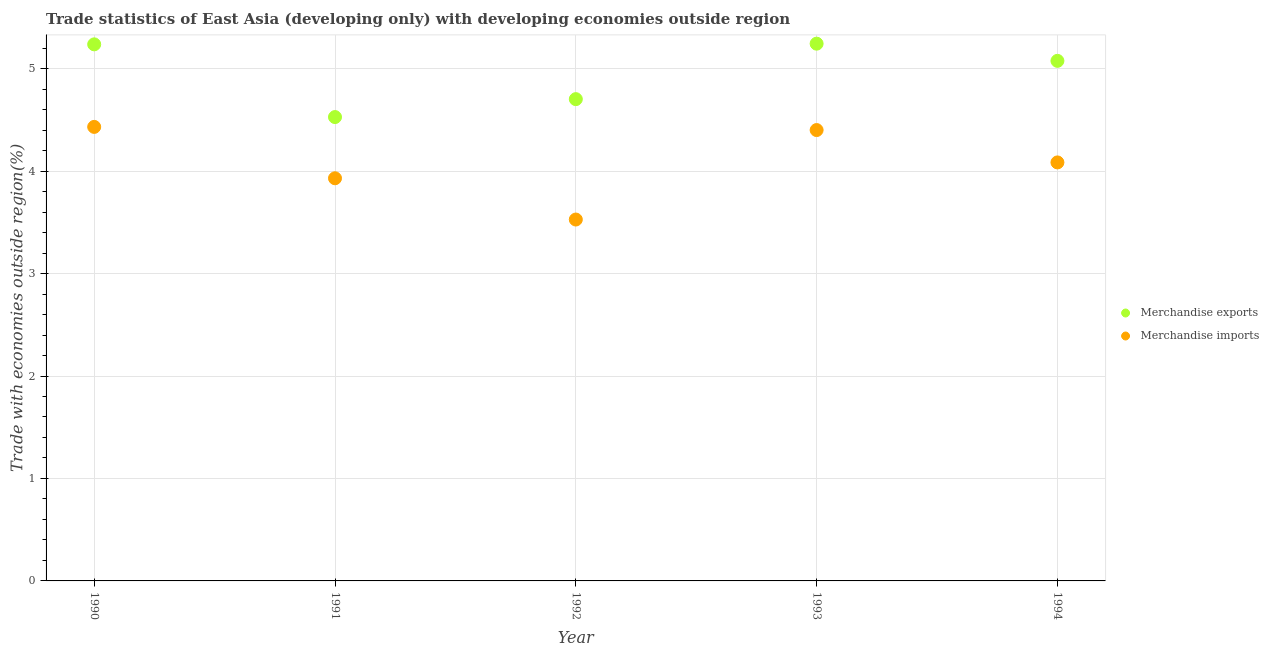What is the merchandise imports in 1993?
Your response must be concise. 4.4. Across all years, what is the maximum merchandise exports?
Give a very brief answer. 5.24. Across all years, what is the minimum merchandise exports?
Keep it short and to the point. 4.53. What is the total merchandise exports in the graph?
Keep it short and to the point. 24.79. What is the difference between the merchandise imports in 1990 and that in 1993?
Provide a succinct answer. 0.03. What is the difference between the merchandise imports in 1994 and the merchandise exports in 1992?
Offer a very short reply. -0.62. What is the average merchandise imports per year?
Your answer should be compact. 4.07. In the year 1990, what is the difference between the merchandise imports and merchandise exports?
Provide a short and direct response. -0.81. What is the ratio of the merchandise imports in 1990 to that in 1994?
Your answer should be compact. 1.08. Is the merchandise exports in 1990 less than that in 1993?
Your answer should be compact. Yes. What is the difference between the highest and the second highest merchandise imports?
Your answer should be compact. 0.03. What is the difference between the highest and the lowest merchandise imports?
Provide a short and direct response. 0.9. Is the merchandise imports strictly less than the merchandise exports over the years?
Provide a short and direct response. Yes. How many dotlines are there?
Offer a terse response. 2. How many years are there in the graph?
Provide a succinct answer. 5. Where does the legend appear in the graph?
Offer a terse response. Center right. What is the title of the graph?
Keep it short and to the point. Trade statistics of East Asia (developing only) with developing economies outside region. Does "Techinal cooperation" appear as one of the legend labels in the graph?
Your answer should be very brief. No. What is the label or title of the X-axis?
Your answer should be very brief. Year. What is the label or title of the Y-axis?
Your response must be concise. Trade with economies outside region(%). What is the Trade with economies outside region(%) in Merchandise exports in 1990?
Make the answer very short. 5.24. What is the Trade with economies outside region(%) in Merchandise imports in 1990?
Provide a succinct answer. 4.43. What is the Trade with economies outside region(%) in Merchandise exports in 1991?
Your answer should be very brief. 4.53. What is the Trade with economies outside region(%) of Merchandise imports in 1991?
Give a very brief answer. 3.93. What is the Trade with economies outside region(%) in Merchandise exports in 1992?
Provide a short and direct response. 4.7. What is the Trade with economies outside region(%) in Merchandise imports in 1992?
Make the answer very short. 3.53. What is the Trade with economies outside region(%) of Merchandise exports in 1993?
Ensure brevity in your answer.  5.24. What is the Trade with economies outside region(%) of Merchandise imports in 1993?
Make the answer very short. 4.4. What is the Trade with economies outside region(%) in Merchandise exports in 1994?
Ensure brevity in your answer.  5.08. What is the Trade with economies outside region(%) in Merchandise imports in 1994?
Provide a short and direct response. 4.08. Across all years, what is the maximum Trade with economies outside region(%) of Merchandise exports?
Provide a succinct answer. 5.24. Across all years, what is the maximum Trade with economies outside region(%) in Merchandise imports?
Offer a terse response. 4.43. Across all years, what is the minimum Trade with economies outside region(%) of Merchandise exports?
Your response must be concise. 4.53. Across all years, what is the minimum Trade with economies outside region(%) of Merchandise imports?
Keep it short and to the point. 3.53. What is the total Trade with economies outside region(%) of Merchandise exports in the graph?
Keep it short and to the point. 24.79. What is the total Trade with economies outside region(%) of Merchandise imports in the graph?
Give a very brief answer. 20.37. What is the difference between the Trade with economies outside region(%) of Merchandise exports in 1990 and that in 1991?
Your answer should be very brief. 0.71. What is the difference between the Trade with economies outside region(%) in Merchandise imports in 1990 and that in 1991?
Offer a terse response. 0.5. What is the difference between the Trade with economies outside region(%) in Merchandise exports in 1990 and that in 1992?
Your answer should be compact. 0.53. What is the difference between the Trade with economies outside region(%) of Merchandise imports in 1990 and that in 1992?
Keep it short and to the point. 0.9. What is the difference between the Trade with economies outside region(%) of Merchandise exports in 1990 and that in 1993?
Offer a terse response. -0.01. What is the difference between the Trade with economies outside region(%) in Merchandise imports in 1990 and that in 1993?
Give a very brief answer. 0.03. What is the difference between the Trade with economies outside region(%) in Merchandise exports in 1990 and that in 1994?
Make the answer very short. 0.16. What is the difference between the Trade with economies outside region(%) of Merchandise imports in 1990 and that in 1994?
Give a very brief answer. 0.35. What is the difference between the Trade with economies outside region(%) of Merchandise exports in 1991 and that in 1992?
Offer a very short reply. -0.17. What is the difference between the Trade with economies outside region(%) in Merchandise imports in 1991 and that in 1992?
Your answer should be very brief. 0.4. What is the difference between the Trade with economies outside region(%) in Merchandise exports in 1991 and that in 1993?
Offer a very short reply. -0.72. What is the difference between the Trade with economies outside region(%) of Merchandise imports in 1991 and that in 1993?
Your answer should be very brief. -0.47. What is the difference between the Trade with economies outside region(%) in Merchandise exports in 1991 and that in 1994?
Provide a short and direct response. -0.55. What is the difference between the Trade with economies outside region(%) of Merchandise imports in 1991 and that in 1994?
Your response must be concise. -0.15. What is the difference between the Trade with economies outside region(%) of Merchandise exports in 1992 and that in 1993?
Offer a very short reply. -0.54. What is the difference between the Trade with economies outside region(%) in Merchandise imports in 1992 and that in 1993?
Offer a terse response. -0.87. What is the difference between the Trade with economies outside region(%) of Merchandise exports in 1992 and that in 1994?
Make the answer very short. -0.37. What is the difference between the Trade with economies outside region(%) in Merchandise imports in 1992 and that in 1994?
Provide a short and direct response. -0.56. What is the difference between the Trade with economies outside region(%) in Merchandise exports in 1993 and that in 1994?
Provide a succinct answer. 0.17. What is the difference between the Trade with economies outside region(%) in Merchandise imports in 1993 and that in 1994?
Provide a succinct answer. 0.32. What is the difference between the Trade with economies outside region(%) in Merchandise exports in 1990 and the Trade with economies outside region(%) in Merchandise imports in 1991?
Your answer should be very brief. 1.31. What is the difference between the Trade with economies outside region(%) in Merchandise exports in 1990 and the Trade with economies outside region(%) in Merchandise imports in 1992?
Keep it short and to the point. 1.71. What is the difference between the Trade with economies outside region(%) in Merchandise exports in 1990 and the Trade with economies outside region(%) in Merchandise imports in 1993?
Provide a succinct answer. 0.84. What is the difference between the Trade with economies outside region(%) in Merchandise exports in 1990 and the Trade with economies outside region(%) in Merchandise imports in 1994?
Keep it short and to the point. 1.15. What is the difference between the Trade with economies outside region(%) of Merchandise exports in 1991 and the Trade with economies outside region(%) of Merchandise imports in 1993?
Make the answer very short. 0.13. What is the difference between the Trade with economies outside region(%) of Merchandise exports in 1991 and the Trade with economies outside region(%) of Merchandise imports in 1994?
Your response must be concise. 0.44. What is the difference between the Trade with economies outside region(%) in Merchandise exports in 1992 and the Trade with economies outside region(%) in Merchandise imports in 1993?
Provide a succinct answer. 0.3. What is the difference between the Trade with economies outside region(%) of Merchandise exports in 1992 and the Trade with economies outside region(%) of Merchandise imports in 1994?
Keep it short and to the point. 0.62. What is the difference between the Trade with economies outside region(%) of Merchandise exports in 1993 and the Trade with economies outside region(%) of Merchandise imports in 1994?
Your answer should be compact. 1.16. What is the average Trade with economies outside region(%) of Merchandise exports per year?
Your answer should be very brief. 4.96. What is the average Trade with economies outside region(%) in Merchandise imports per year?
Provide a succinct answer. 4.07. In the year 1990, what is the difference between the Trade with economies outside region(%) in Merchandise exports and Trade with economies outside region(%) in Merchandise imports?
Your answer should be compact. 0.81. In the year 1991, what is the difference between the Trade with economies outside region(%) of Merchandise exports and Trade with economies outside region(%) of Merchandise imports?
Your response must be concise. 0.6. In the year 1992, what is the difference between the Trade with economies outside region(%) of Merchandise exports and Trade with economies outside region(%) of Merchandise imports?
Ensure brevity in your answer.  1.18. In the year 1993, what is the difference between the Trade with economies outside region(%) of Merchandise exports and Trade with economies outside region(%) of Merchandise imports?
Your response must be concise. 0.84. What is the ratio of the Trade with economies outside region(%) of Merchandise exports in 1990 to that in 1991?
Make the answer very short. 1.16. What is the ratio of the Trade with economies outside region(%) of Merchandise imports in 1990 to that in 1991?
Provide a short and direct response. 1.13. What is the ratio of the Trade with economies outside region(%) in Merchandise exports in 1990 to that in 1992?
Your response must be concise. 1.11. What is the ratio of the Trade with economies outside region(%) of Merchandise imports in 1990 to that in 1992?
Keep it short and to the point. 1.26. What is the ratio of the Trade with economies outside region(%) in Merchandise exports in 1990 to that in 1993?
Provide a succinct answer. 1. What is the ratio of the Trade with economies outside region(%) of Merchandise exports in 1990 to that in 1994?
Your answer should be compact. 1.03. What is the ratio of the Trade with economies outside region(%) in Merchandise imports in 1990 to that in 1994?
Provide a succinct answer. 1.08. What is the ratio of the Trade with economies outside region(%) in Merchandise exports in 1991 to that in 1992?
Your response must be concise. 0.96. What is the ratio of the Trade with economies outside region(%) of Merchandise imports in 1991 to that in 1992?
Your response must be concise. 1.11. What is the ratio of the Trade with economies outside region(%) of Merchandise exports in 1991 to that in 1993?
Ensure brevity in your answer.  0.86. What is the ratio of the Trade with economies outside region(%) of Merchandise imports in 1991 to that in 1993?
Give a very brief answer. 0.89. What is the ratio of the Trade with economies outside region(%) of Merchandise exports in 1991 to that in 1994?
Provide a succinct answer. 0.89. What is the ratio of the Trade with economies outside region(%) in Merchandise imports in 1991 to that in 1994?
Your answer should be very brief. 0.96. What is the ratio of the Trade with economies outside region(%) in Merchandise exports in 1992 to that in 1993?
Your answer should be compact. 0.9. What is the ratio of the Trade with economies outside region(%) of Merchandise imports in 1992 to that in 1993?
Your response must be concise. 0.8. What is the ratio of the Trade with economies outside region(%) in Merchandise exports in 1992 to that in 1994?
Offer a terse response. 0.93. What is the ratio of the Trade with economies outside region(%) in Merchandise imports in 1992 to that in 1994?
Offer a very short reply. 0.86. What is the ratio of the Trade with economies outside region(%) in Merchandise exports in 1993 to that in 1994?
Ensure brevity in your answer.  1.03. What is the ratio of the Trade with economies outside region(%) in Merchandise imports in 1993 to that in 1994?
Give a very brief answer. 1.08. What is the difference between the highest and the second highest Trade with economies outside region(%) of Merchandise exports?
Your answer should be compact. 0.01. What is the difference between the highest and the second highest Trade with economies outside region(%) in Merchandise imports?
Make the answer very short. 0.03. What is the difference between the highest and the lowest Trade with economies outside region(%) in Merchandise exports?
Your response must be concise. 0.72. What is the difference between the highest and the lowest Trade with economies outside region(%) of Merchandise imports?
Your response must be concise. 0.9. 